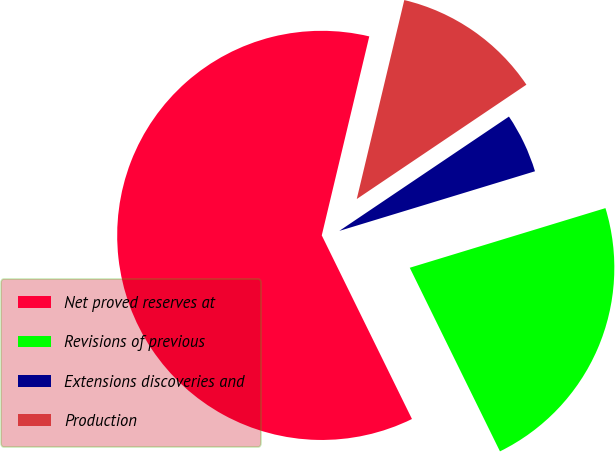<chart> <loc_0><loc_0><loc_500><loc_500><pie_chart><fcel>Net proved reserves at<fcel>Revisions of previous<fcel>Extensions discoveries and<fcel>Production<nl><fcel>61.0%<fcel>22.44%<fcel>4.73%<fcel>11.83%<nl></chart> 